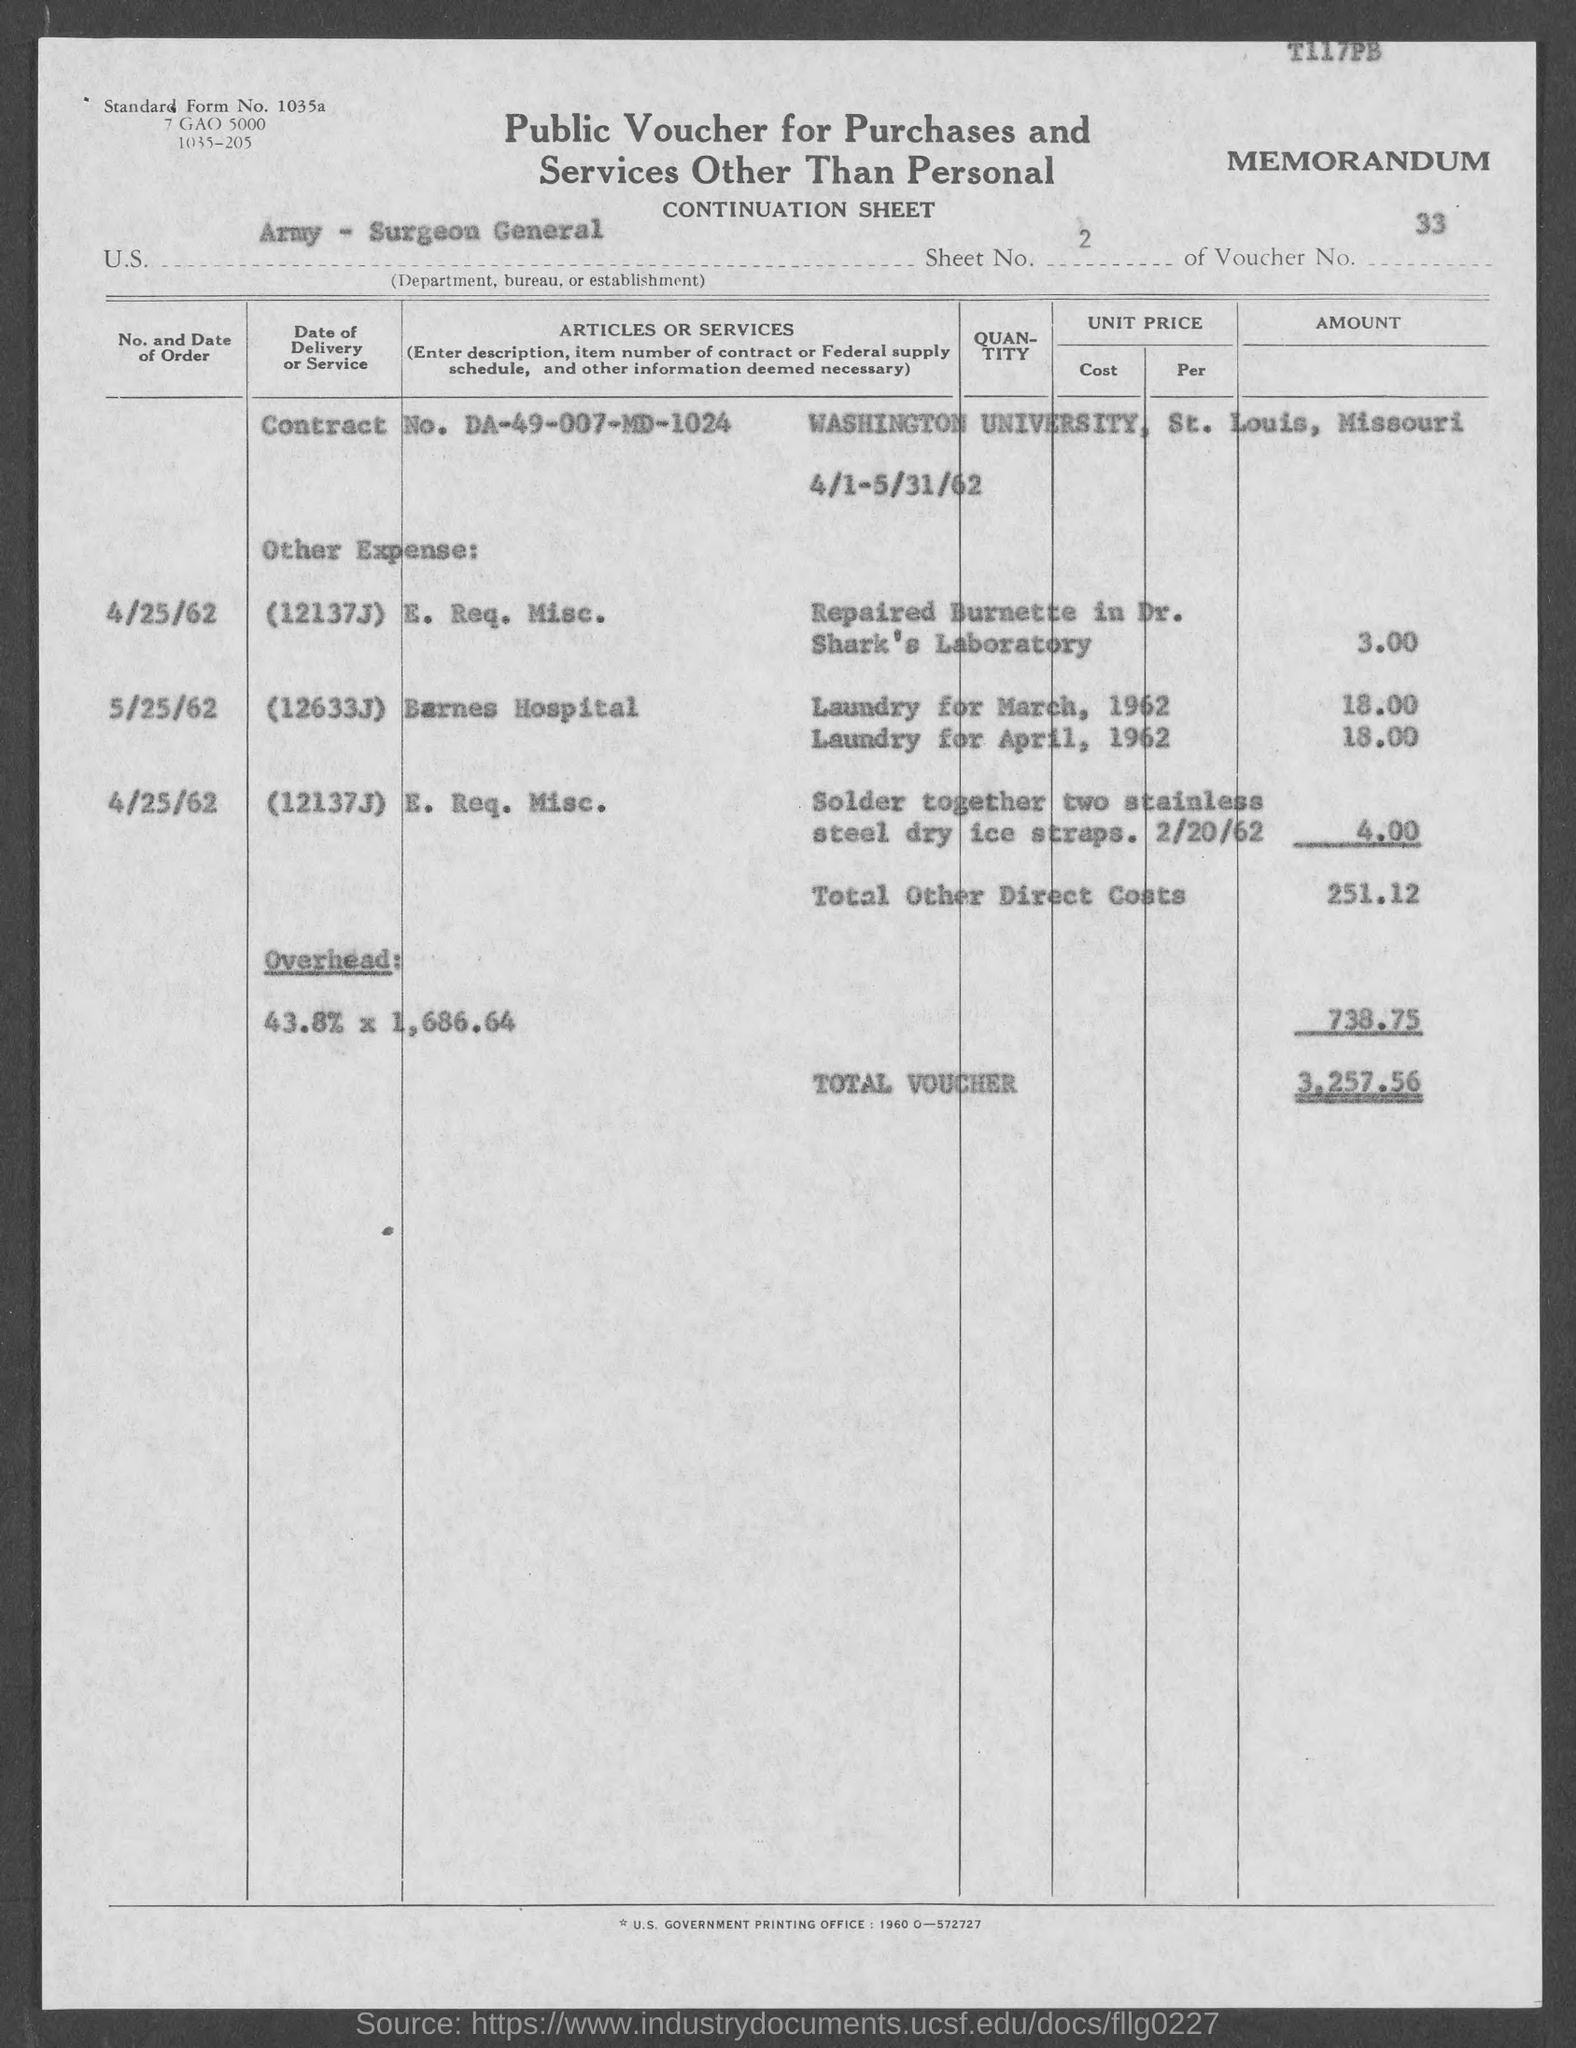What is the Sheet No.?
Make the answer very short. 2. What is the voucher no?
Provide a succinct answer. 33. What is the total voucher?
Your answer should be compact. 3,257.56. 